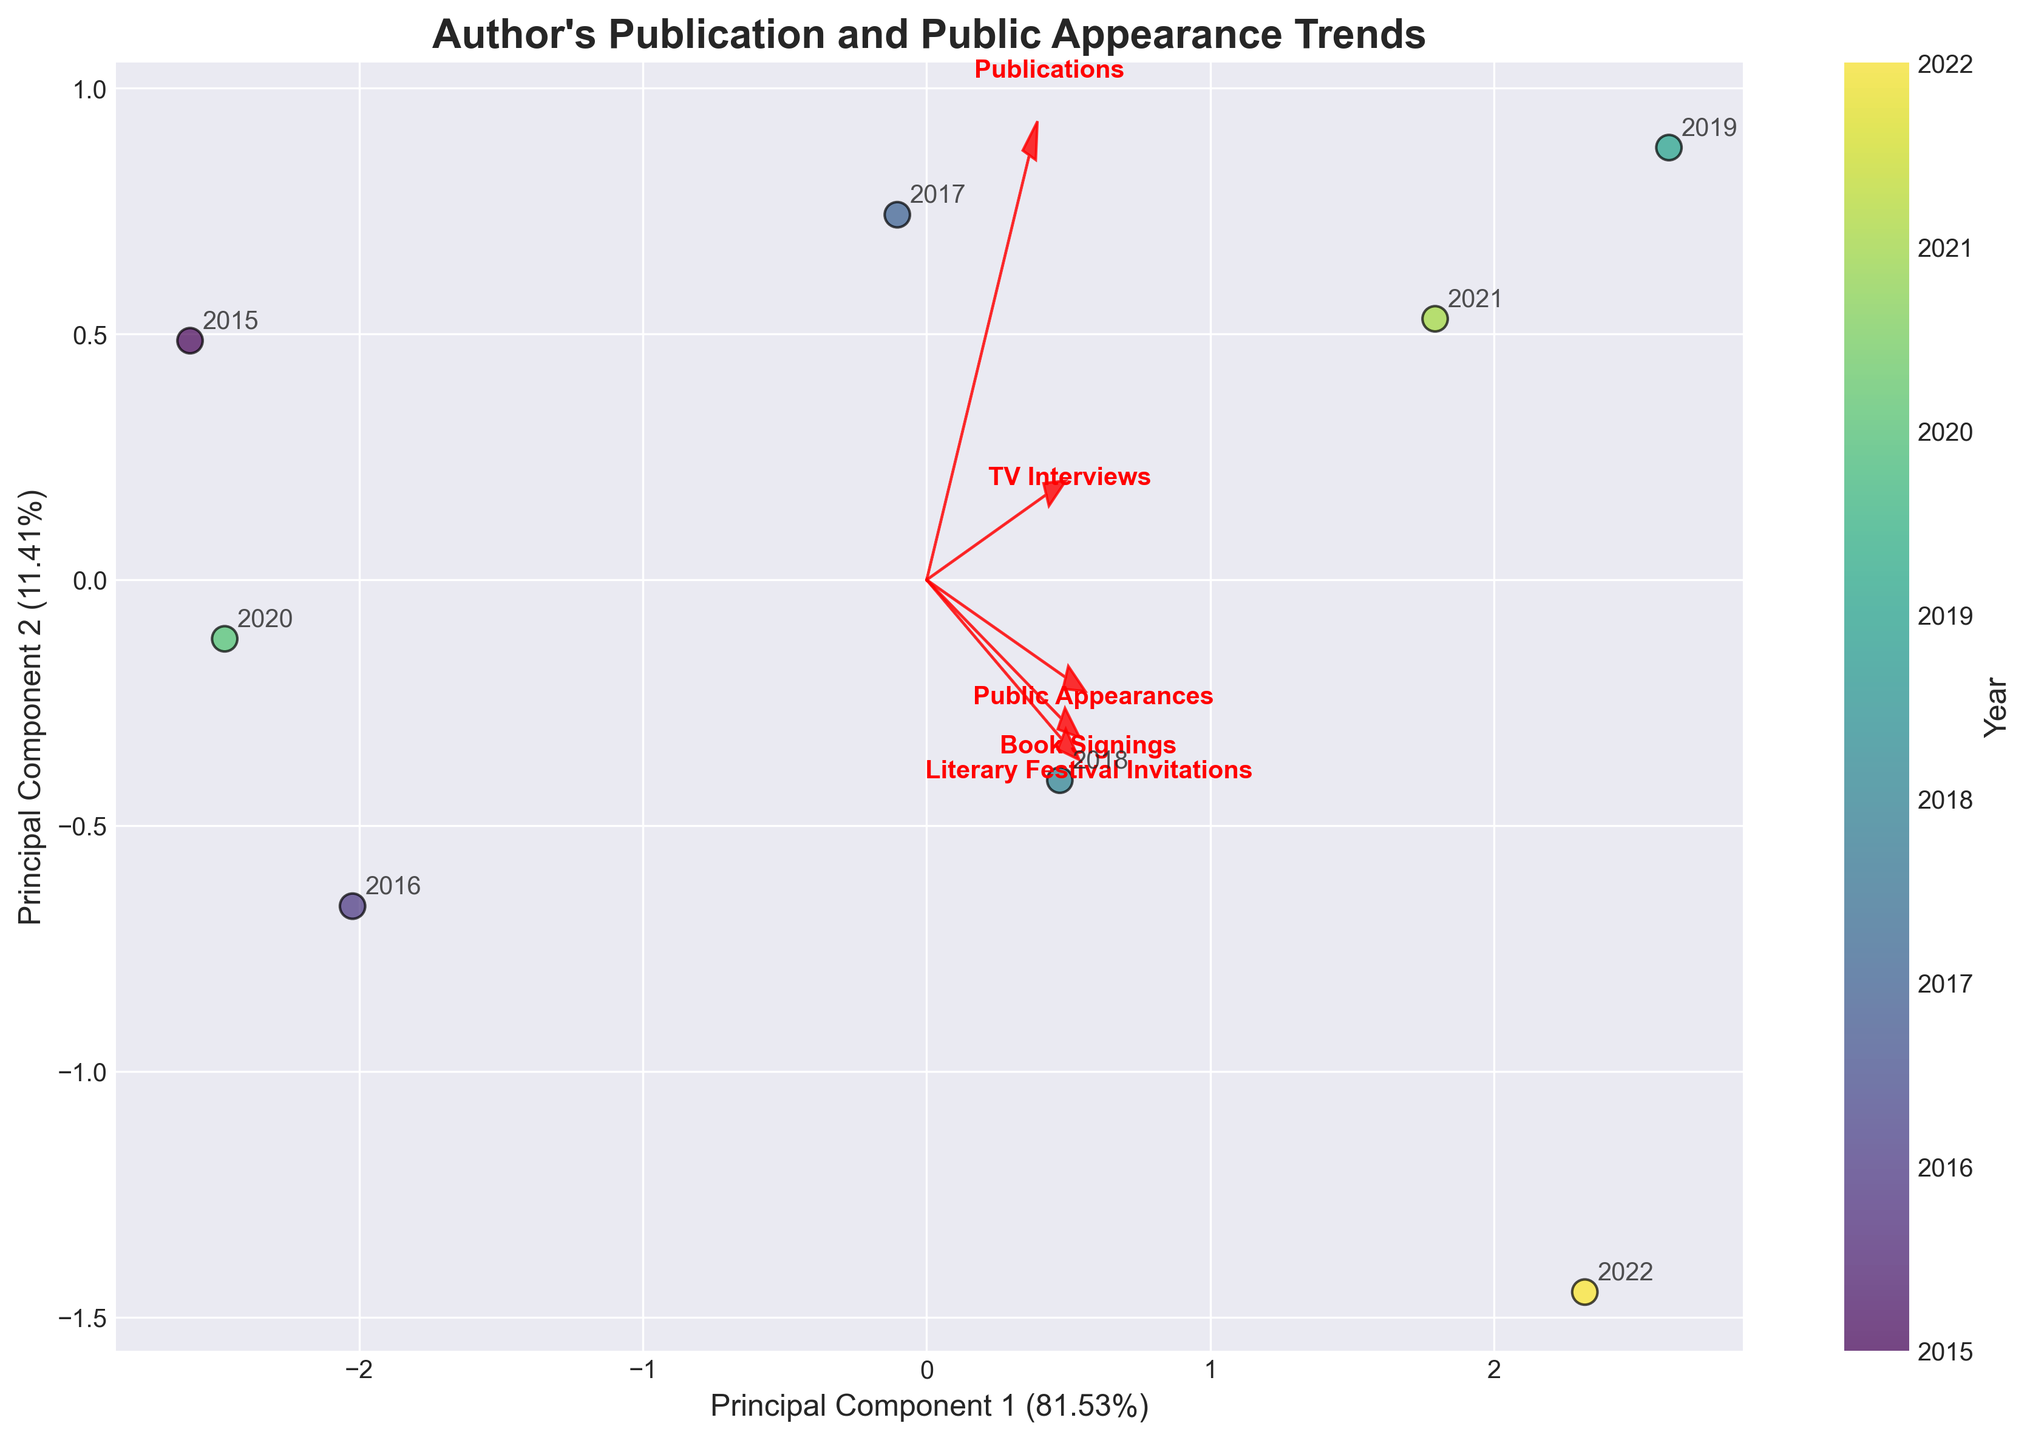What's the title of the figure? Look at the top part of the figure where the title is usually placed.
Answer: "Author's Publication and Public Appearance Trends" What does the color of the data points represent? Check the color bar next to the scatter plot; it should explain what the colors indicate.
Answer: Year How many data points are there in the figure? Count the number of scatter points present in the plot.
Answer: 8 Which two features have the longest vectors in the figure? Observe the feature vectors denoted by arrows in the plot; the lengths indicate the strength of each feature in the PCA dimensions.
Answer: Public Appearances and TV Interviews What percentage of the variance is explained by Principal Component 1? Look at the label of the x-axis, which mentions the percentage of variance explained by Principal Component 1.
Answer: 47.77% What percentage of the variance is explained by Principal Component 2? Check the label of the y-axis, which mentions the percentage of variance explained by Principal Component 2.
Answer: 33.77% Which year is closest to the origin (0, 0)? Find the data point that is nearest to the origin and read its annotated year.
Answer: 2020 How is the year 2019 positioned in the plot compared to 2020? Identify both years' positions; observe and compare the location of 2019 relative to 2020 in terms of PC1 and PC2 coordinates.
Answer: 2019 is further from the origin on both PC1 and PC2 Which feature has the smallest impact on Principal Component 2? Observe the length of the feature vectors along the PC2 axis and find the shortest one.
Answer: Publications What is the trend for "Public Appearances" over the years? Look at the direction and length of the "Public Appearances" vector and compare the positions of different years along this vector.
Answer: Increasing 